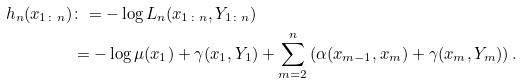<formula> <loc_0><loc_0><loc_500><loc_500>h _ { n } ( x _ { 1 \colon n } ) & \colon = - \log L _ { n } ( x _ { 1 \colon n } , Y _ { 1 \colon n } ) \\ & = - \log \mu ( x _ { 1 } ) + \gamma ( x _ { 1 } , Y _ { 1 } ) + \sum _ { m = 2 } ^ { n } \left ( \alpha ( x _ { m - 1 } , x _ { m } ) + \gamma ( x _ { m } , Y _ { m } ) \right ) .</formula> 